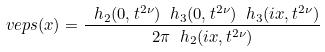<formula> <loc_0><loc_0><loc_500><loc_500>\ v e p s ( x ) = \frac { \ h _ { 2 } ( 0 , t ^ { 2 \nu } ) \ h _ { 3 } ( 0 , t ^ { 2 \nu } ) \ h _ { 3 } ( i x , t ^ { 2 \nu } ) } { 2 \pi \ h _ { 2 } ( i x , t ^ { 2 \nu } ) }</formula> 